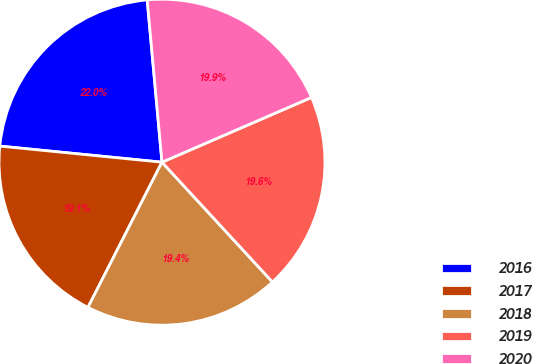Convert chart to OTSL. <chart><loc_0><loc_0><loc_500><loc_500><pie_chart><fcel>2016<fcel>2017<fcel>2018<fcel>2019<fcel>2020<nl><fcel>21.98%<fcel>19.07%<fcel>19.36%<fcel>19.65%<fcel>19.94%<nl></chart> 